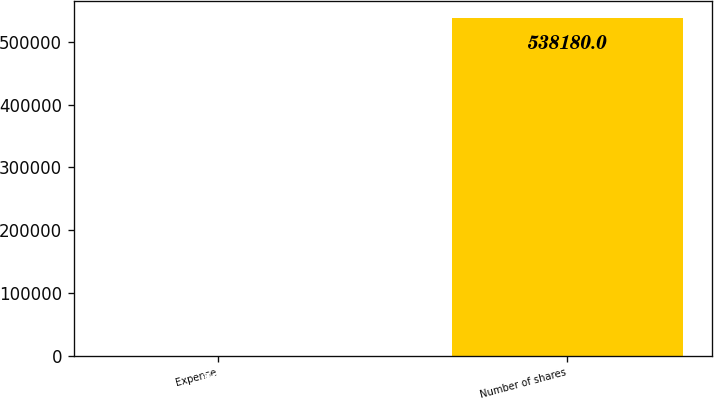Convert chart to OTSL. <chart><loc_0><loc_0><loc_500><loc_500><bar_chart><fcel>Expense<fcel>Number of shares<nl><fcel>26.3<fcel>538180<nl></chart> 